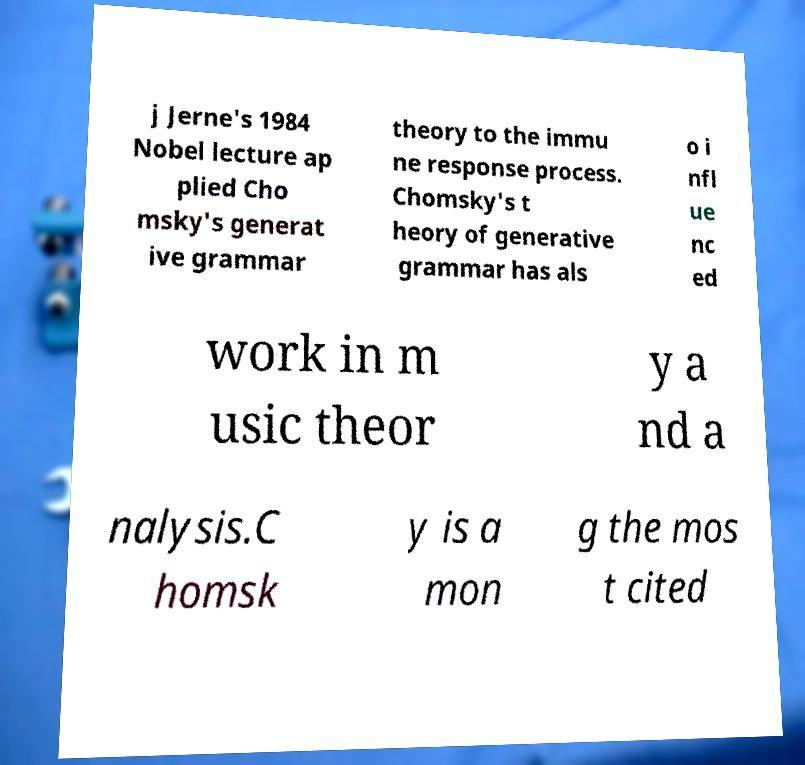Could you extract and type out the text from this image? j Jerne's 1984 Nobel lecture ap plied Cho msky's generat ive grammar theory to the immu ne response process. Chomsky's t heory of generative grammar has als o i nfl ue nc ed work in m usic theor y a nd a nalysis.C homsk y is a mon g the mos t cited 